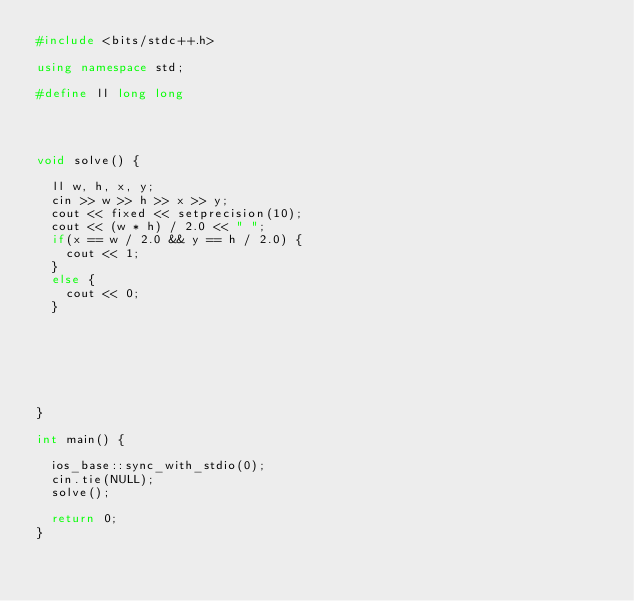Convert code to text. <code><loc_0><loc_0><loc_500><loc_500><_C++_>#include <bits/stdc++.h>

using namespace std;

#define ll long long




void solve() {

	ll w, h, x, y;
	cin >> w >> h >> x >> y;
	cout << fixed << setprecision(10);
	cout << (w * h) / 2.0 << " ";
	if(x == w / 2.0 && y == h / 2.0) {
		cout << 1;
	}
	else {
		cout << 0;
	}

	




	
}

int main() {

	ios_base::sync_with_stdio(0);
	cin.tie(NULL);
	solve();

	return 0;
}</code> 